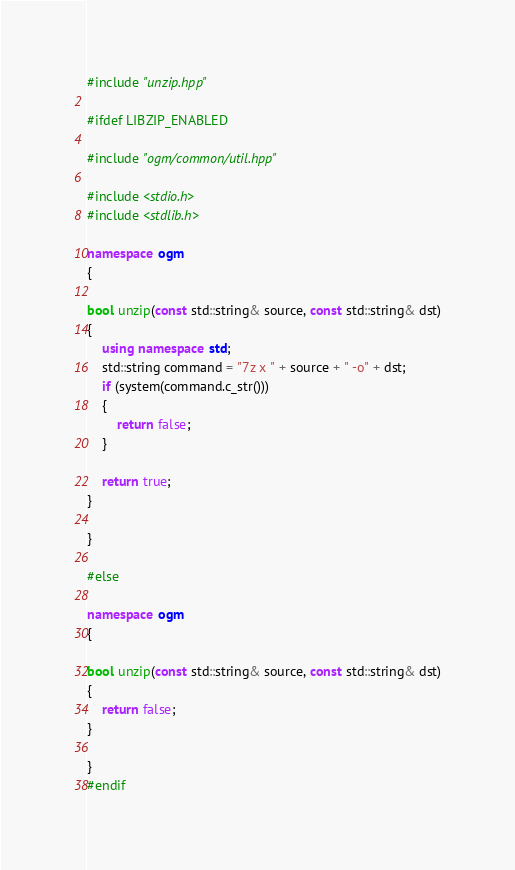Convert code to text. <code><loc_0><loc_0><loc_500><loc_500><_C++_>#include "unzip.hpp"

#ifdef LIBZIP_ENABLED

#include "ogm/common/util.hpp"

#include <stdio.h>
#include <stdlib.h>

namespace ogm
{

bool unzip(const std::string& source, const std::string& dst)
{
    using namespace std;
    std::string command = "7z x " + source + " -o" + dst;
    if (system(command.c_str()))
    {
        return false;
    }

    return true;
}

}

#else

namespace ogm
{

bool unzip(const std::string& source, const std::string& dst)
{
    return false;
}

}
#endif
</code> 